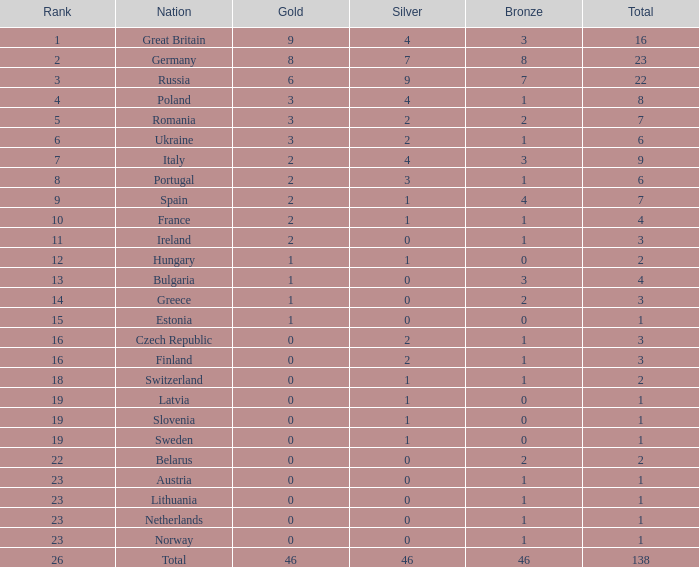What is the country with a total score above 1, under 3 bronze, above 2 silver, and more than 2 gold medals? Poland. 